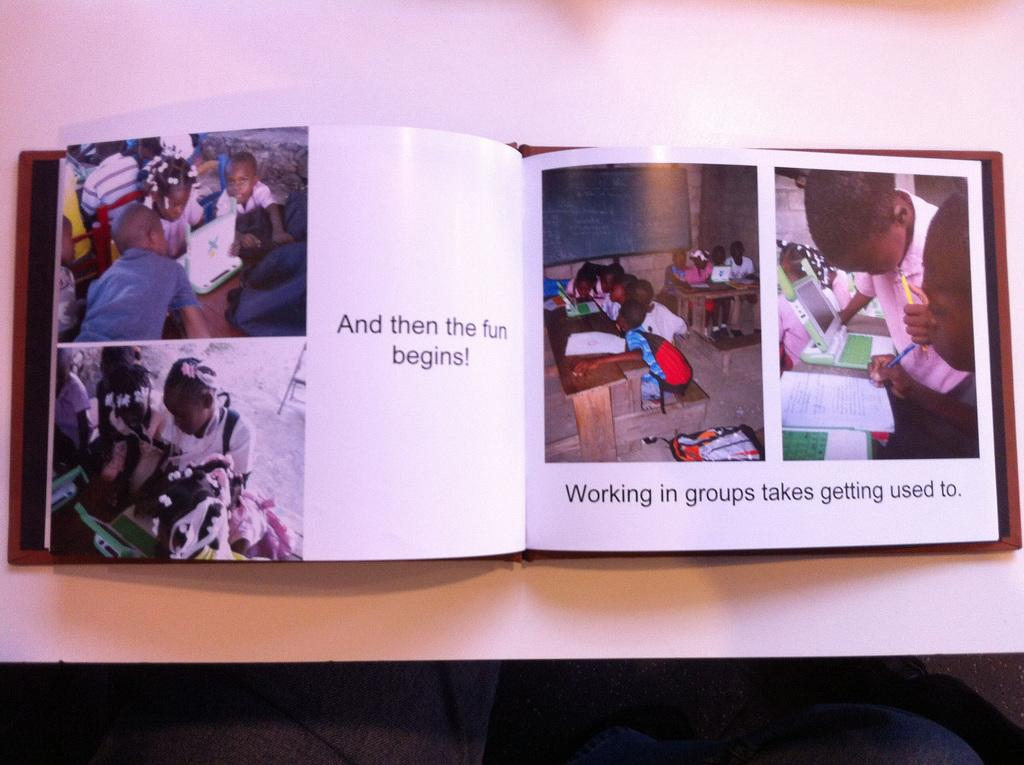<image>
Give a short and clear explanation of the subsequent image. a picture book that says 'and then the fun begins!' on it 